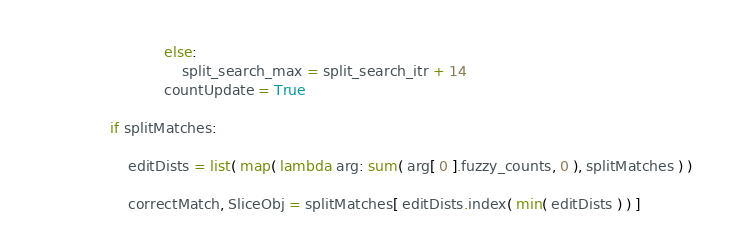Convert code to text. <code><loc_0><loc_0><loc_500><loc_500><_Python_>                            else:
                                split_search_max = split_search_itr + 14
                            countUpdate = True

                if splitMatches:

                    editDists = list( map( lambda arg: sum( arg[ 0 ].fuzzy_counts, 0 ), splitMatches ) )

                    correctMatch, SliceObj = splitMatches[ editDists.index( min( editDists ) ) ]
</code> 